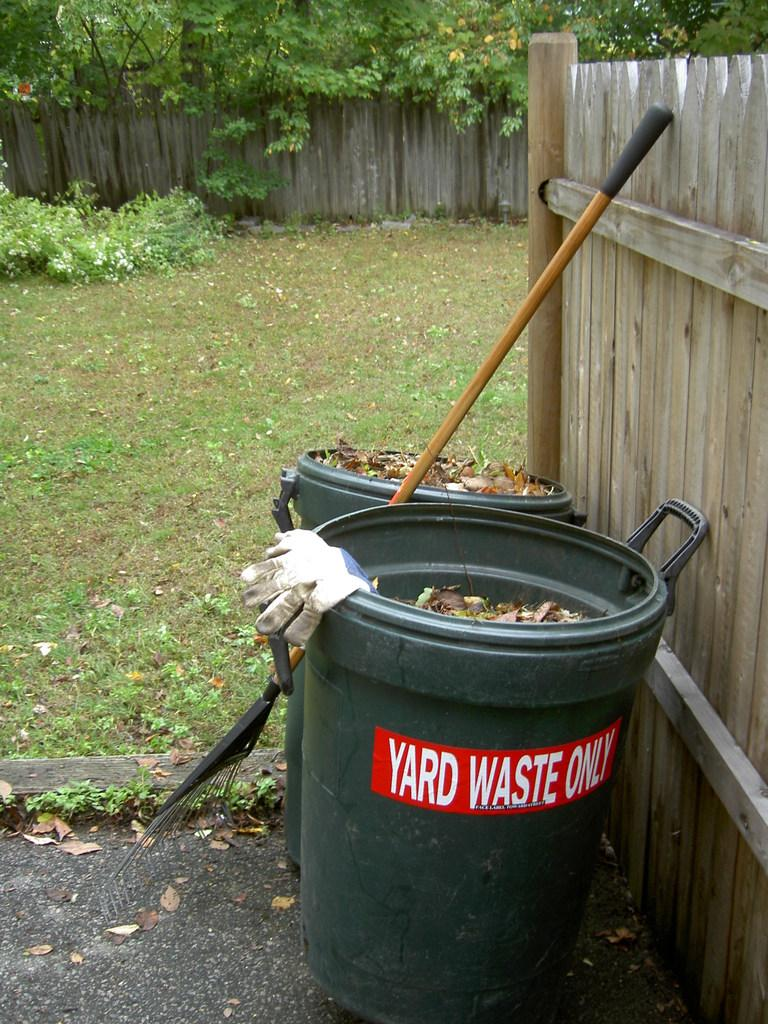<image>
Provide a brief description of the given image. A large green bin that has a yard waste only sticker on it. 